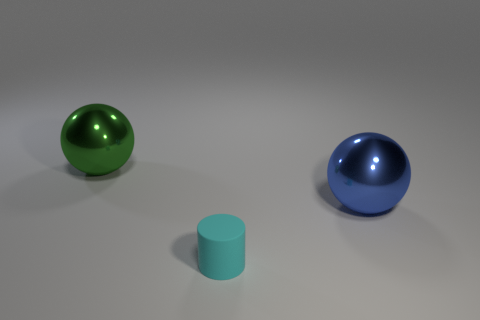There is a cyan object; how many large shiny balls are on the right side of it?
Keep it short and to the point. 1. Do the large metal thing behind the large blue shiny object and the small rubber thing have the same color?
Your answer should be very brief. No. How many cylinders are the same size as the blue ball?
Provide a short and direct response. 0. There is a big object that is the same material as the green ball; what is its shape?
Make the answer very short. Sphere. Is there a shiny thing of the same color as the tiny cylinder?
Your answer should be very brief. No. What material is the green object?
Your answer should be compact. Metal. What number of objects are cyan cylinders or big shiny balls?
Your answer should be compact. 3. There is a metal ball that is in front of the large green sphere; what is its size?
Your answer should be compact. Large. How many other objects are the same material as the green thing?
Give a very brief answer. 1. There is a big object on the right side of the cyan rubber object; are there any tiny cyan cylinders behind it?
Give a very brief answer. No. 